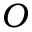<formula> <loc_0><loc_0><loc_500><loc_500>O</formula> 